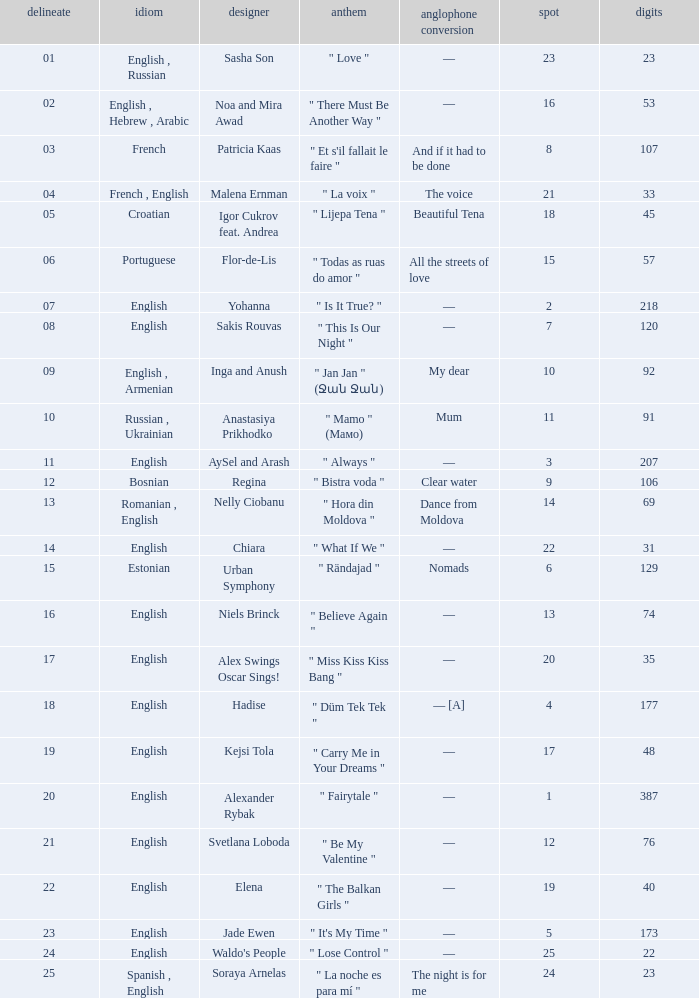What song was in french? " Et s'il fallait le faire ". 